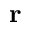<formula> <loc_0><loc_0><loc_500><loc_500>r</formula> 